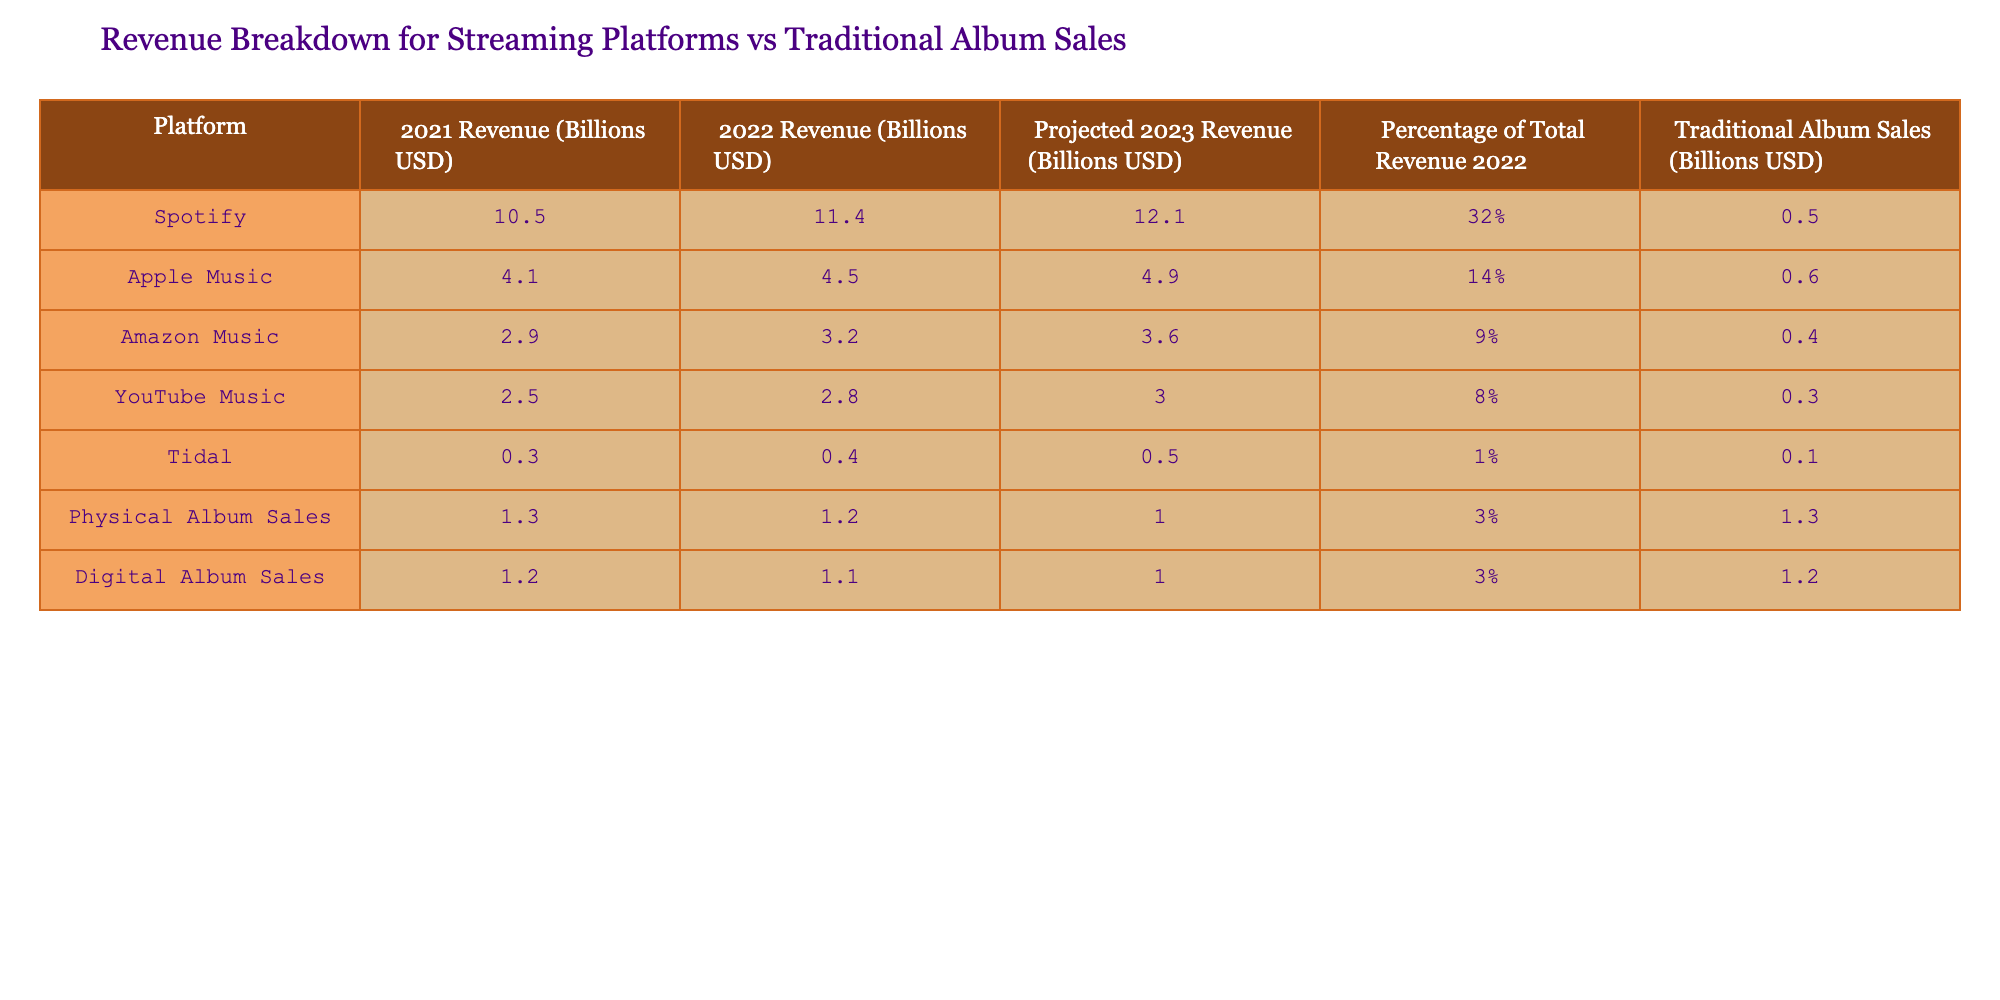What was the revenue for Spotify in 2022? In the table under the column "2022 Revenue (Billions USD)" for Spotify, the value listed is 11.4 billion USD. Therefore, the revenue is taken directly from that cell.
Answer: 11.4 billion USD Which platform had the lowest revenue in 2021? To find the lowest revenue in 2021, compare the values listed in the "2021 Revenue (Billions USD)" column. The values are 10.5 (Spotify), 4.1 (Apple Music), 2.9 (Amazon Music), 2.5 (YouTube Music), 0.3 (Tidal), 1.3 (Physical Album Sales), and 1.2 (Digital Album Sales). The lowest among these is 0.3 billion USD for Tidal.
Answer: Tidal What is the percentage of total revenue represented by Physical Album Sales in 2022? The table shows that Physical Album Sales represent 3% of the total revenue in 2022, which is stated explicitly in the "Percentage of Total Revenue 2022" column for that row.
Answer: 3% How much more revenue did Spotify generate than Amazon Music in 2022? For the year 2022, Spotify had a revenue of 11.4 billion USD and Amazon Music had a revenue of 3.2 billion USD. To find the difference, subtract the revenue of Amazon Music from that of Spotify: 11.4 - 3.2 = 8.2 billion USD.
Answer: 8.2 billion USD What is the total projected revenue for all streaming platforms in 2023? To find the total projected revenue for all streaming platforms in 2023, sum the projected revenues for Spotify (12.1), Apple Music (4.9), Amazon Music (3.6), YouTube Music (3.0), and Tidal (0.5): 12.1 + 4.9 + 3.6 + 3.0 + 0.5 = 24.1 billion USD.
Answer: 24.1 billion USD Are Digital Album Sales projected to decrease from 2022 to 2023? The projected revenue for Digital Album Sales is 1.0 billion USD for 2023, while the revenue for 2022 is listed as 1.1 billion USD. Since 1.0 billion is less than 1.1 billion, it indicates a decrease.
Answer: Yes Which streaming platform is projected to have the highest revenue in 2023? Looking at the "Projected 2023 Revenue (Billions USD)" column, Spotify has the highest value at 12.1 billion USD compared to other platforms listed.
Answer: Spotify What is the total revenue from Traditional Album Sales in 2022? The total revenue from Traditional Album Sales in 2022 is shown in the "Traditional Album Sales (Billions USD)" column as 1.3 billion USD. No calculations are needed because it is directly listed.
Answer: 1.3 billion USD 